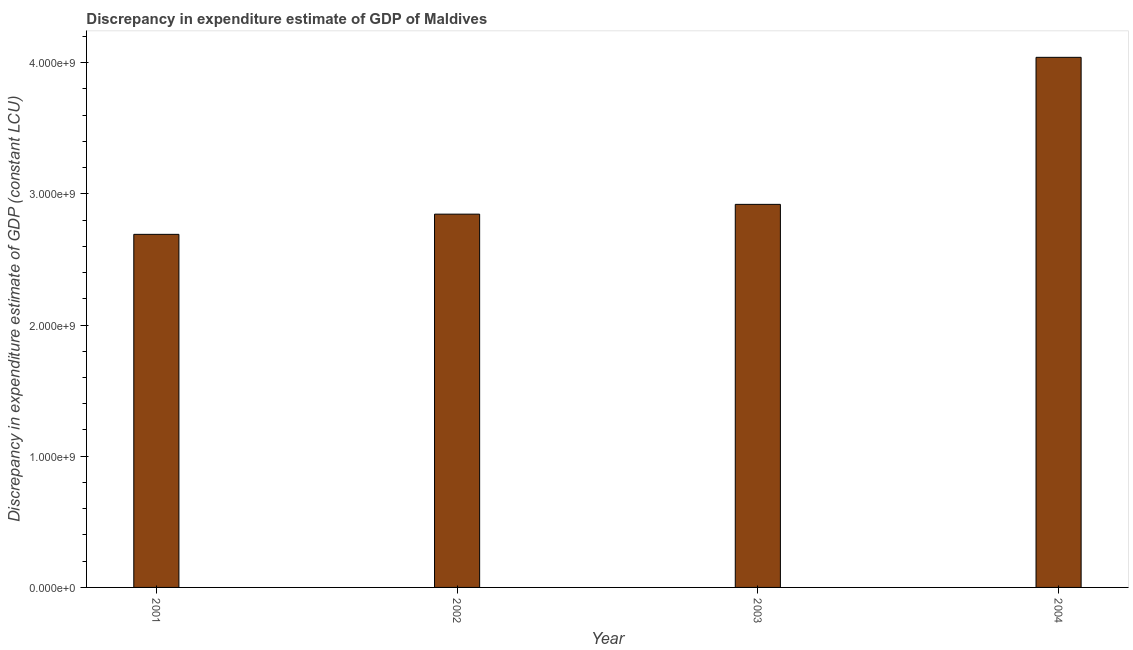Does the graph contain any zero values?
Offer a very short reply. No. What is the title of the graph?
Provide a succinct answer. Discrepancy in expenditure estimate of GDP of Maldives. What is the label or title of the Y-axis?
Your answer should be very brief. Discrepancy in expenditure estimate of GDP (constant LCU). What is the discrepancy in expenditure estimate of gdp in 2001?
Your answer should be compact. 2.69e+09. Across all years, what is the maximum discrepancy in expenditure estimate of gdp?
Give a very brief answer. 4.04e+09. Across all years, what is the minimum discrepancy in expenditure estimate of gdp?
Ensure brevity in your answer.  2.69e+09. In which year was the discrepancy in expenditure estimate of gdp minimum?
Your answer should be very brief. 2001. What is the sum of the discrepancy in expenditure estimate of gdp?
Provide a succinct answer. 1.25e+1. What is the difference between the discrepancy in expenditure estimate of gdp in 2003 and 2004?
Offer a terse response. -1.12e+09. What is the average discrepancy in expenditure estimate of gdp per year?
Ensure brevity in your answer.  3.12e+09. What is the median discrepancy in expenditure estimate of gdp?
Provide a succinct answer. 2.88e+09. In how many years, is the discrepancy in expenditure estimate of gdp greater than 2600000000 LCU?
Your answer should be compact. 4. What is the ratio of the discrepancy in expenditure estimate of gdp in 2002 to that in 2004?
Keep it short and to the point. 0.7. Is the discrepancy in expenditure estimate of gdp in 2003 less than that in 2004?
Keep it short and to the point. Yes. What is the difference between the highest and the second highest discrepancy in expenditure estimate of gdp?
Provide a succinct answer. 1.12e+09. Is the sum of the discrepancy in expenditure estimate of gdp in 2002 and 2003 greater than the maximum discrepancy in expenditure estimate of gdp across all years?
Ensure brevity in your answer.  Yes. What is the difference between the highest and the lowest discrepancy in expenditure estimate of gdp?
Give a very brief answer. 1.35e+09. In how many years, is the discrepancy in expenditure estimate of gdp greater than the average discrepancy in expenditure estimate of gdp taken over all years?
Your response must be concise. 1. What is the difference between two consecutive major ticks on the Y-axis?
Keep it short and to the point. 1.00e+09. Are the values on the major ticks of Y-axis written in scientific E-notation?
Your answer should be compact. Yes. What is the Discrepancy in expenditure estimate of GDP (constant LCU) of 2001?
Offer a terse response. 2.69e+09. What is the Discrepancy in expenditure estimate of GDP (constant LCU) of 2002?
Ensure brevity in your answer.  2.85e+09. What is the Discrepancy in expenditure estimate of GDP (constant LCU) in 2003?
Your answer should be compact. 2.92e+09. What is the Discrepancy in expenditure estimate of GDP (constant LCU) in 2004?
Give a very brief answer. 4.04e+09. What is the difference between the Discrepancy in expenditure estimate of GDP (constant LCU) in 2001 and 2002?
Make the answer very short. -1.54e+08. What is the difference between the Discrepancy in expenditure estimate of GDP (constant LCU) in 2001 and 2003?
Provide a succinct answer. -2.29e+08. What is the difference between the Discrepancy in expenditure estimate of GDP (constant LCU) in 2001 and 2004?
Keep it short and to the point. -1.35e+09. What is the difference between the Discrepancy in expenditure estimate of GDP (constant LCU) in 2002 and 2003?
Offer a terse response. -7.45e+07. What is the difference between the Discrepancy in expenditure estimate of GDP (constant LCU) in 2002 and 2004?
Provide a short and direct response. -1.20e+09. What is the difference between the Discrepancy in expenditure estimate of GDP (constant LCU) in 2003 and 2004?
Make the answer very short. -1.12e+09. What is the ratio of the Discrepancy in expenditure estimate of GDP (constant LCU) in 2001 to that in 2002?
Your response must be concise. 0.95. What is the ratio of the Discrepancy in expenditure estimate of GDP (constant LCU) in 2001 to that in 2003?
Offer a terse response. 0.92. What is the ratio of the Discrepancy in expenditure estimate of GDP (constant LCU) in 2001 to that in 2004?
Provide a short and direct response. 0.67. What is the ratio of the Discrepancy in expenditure estimate of GDP (constant LCU) in 2002 to that in 2004?
Your response must be concise. 0.7. What is the ratio of the Discrepancy in expenditure estimate of GDP (constant LCU) in 2003 to that in 2004?
Provide a short and direct response. 0.72. 